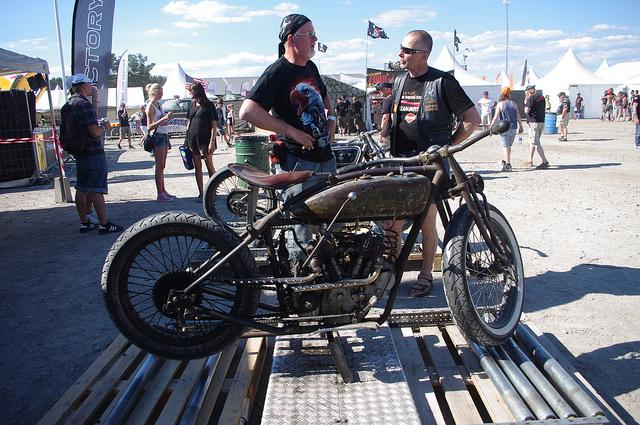What material are the pipes which are holding up the old bike?

Choices:
A) concrete
B) wood
C) sand
D) plastic wood 